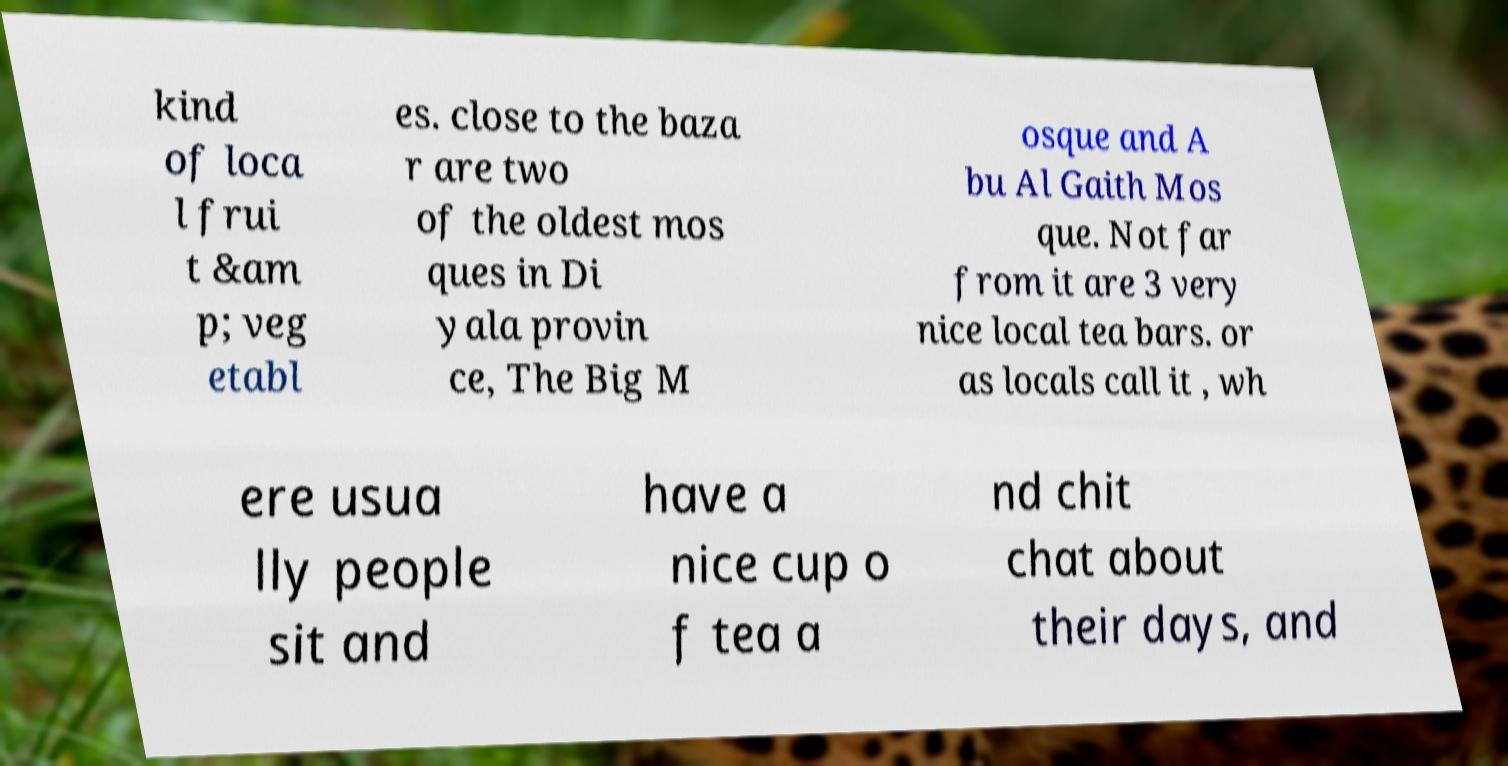For documentation purposes, I need the text within this image transcribed. Could you provide that? kind of loca l frui t &am p; veg etabl es. close to the baza r are two of the oldest mos ques in Di yala provin ce, The Big M osque and A bu Al Gaith Mos que. Not far from it are 3 very nice local tea bars. or as locals call it , wh ere usua lly people sit and have a nice cup o f tea a nd chit chat about their days, and 